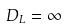<formula> <loc_0><loc_0><loc_500><loc_500>D _ { L } = \infty</formula> 